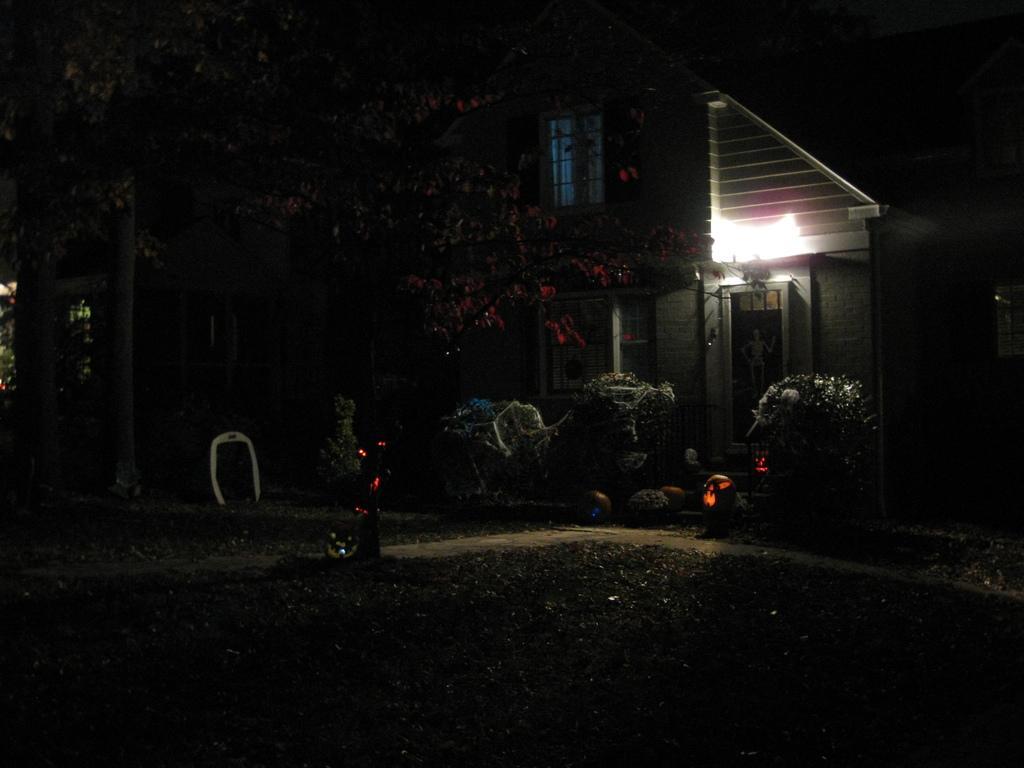Please provide a concise description of this image. This is clicked at night time, there is a building on the back with plants and trees in front of it and there is a garden in the front. 